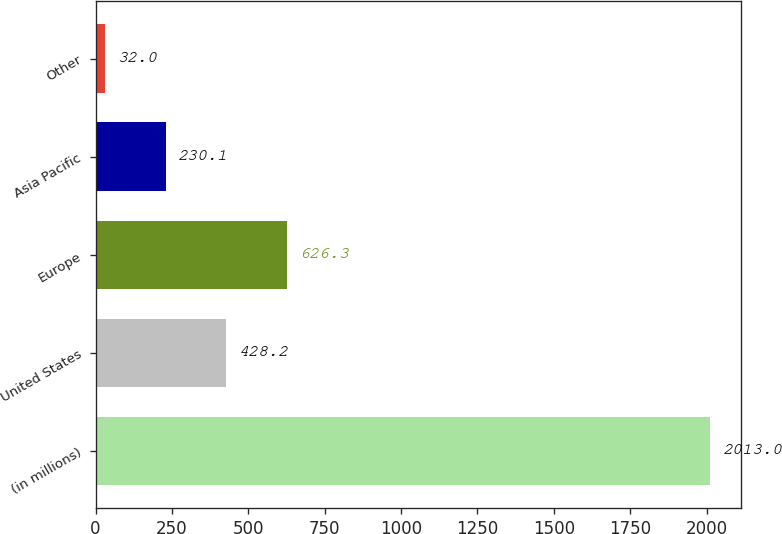Convert chart. <chart><loc_0><loc_0><loc_500><loc_500><bar_chart><fcel>(in millions)<fcel>United States<fcel>Europe<fcel>Asia Pacific<fcel>Other<nl><fcel>2013<fcel>428.2<fcel>626.3<fcel>230.1<fcel>32<nl></chart> 